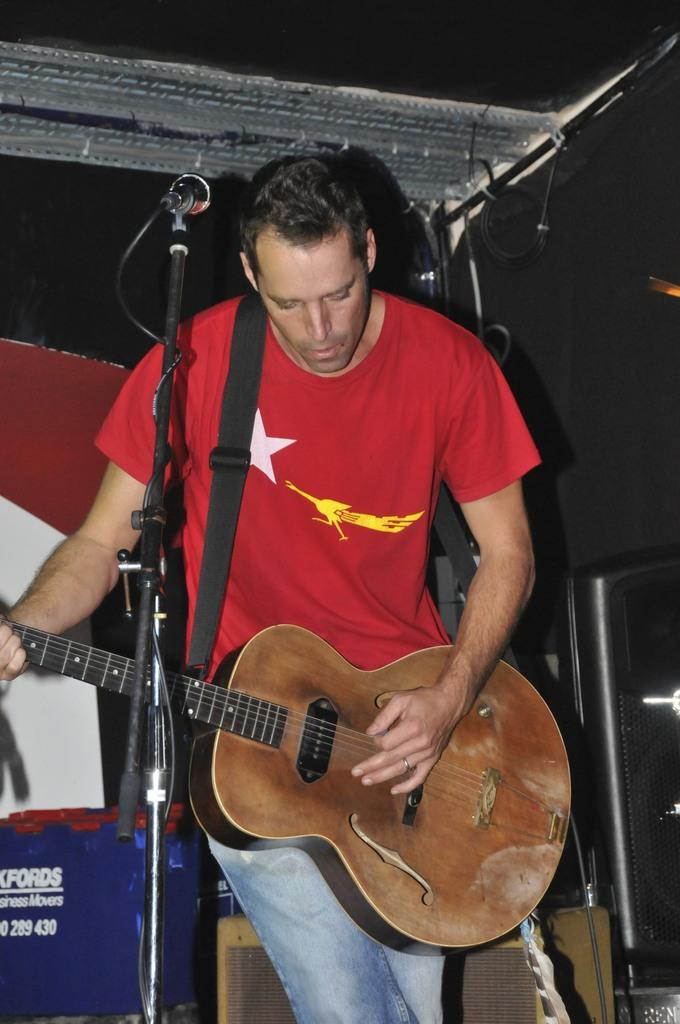What is the main subject of the image? There is a man standing in the center of the image. What is the man doing in the image? The man is playing a guitar. What object is visible near the man? There is a microphone visible in the image. What type of territory is the man trying to claim in the image? There is no indication of territory in the image; it simply shows a man playing a guitar with a microphone nearby. 